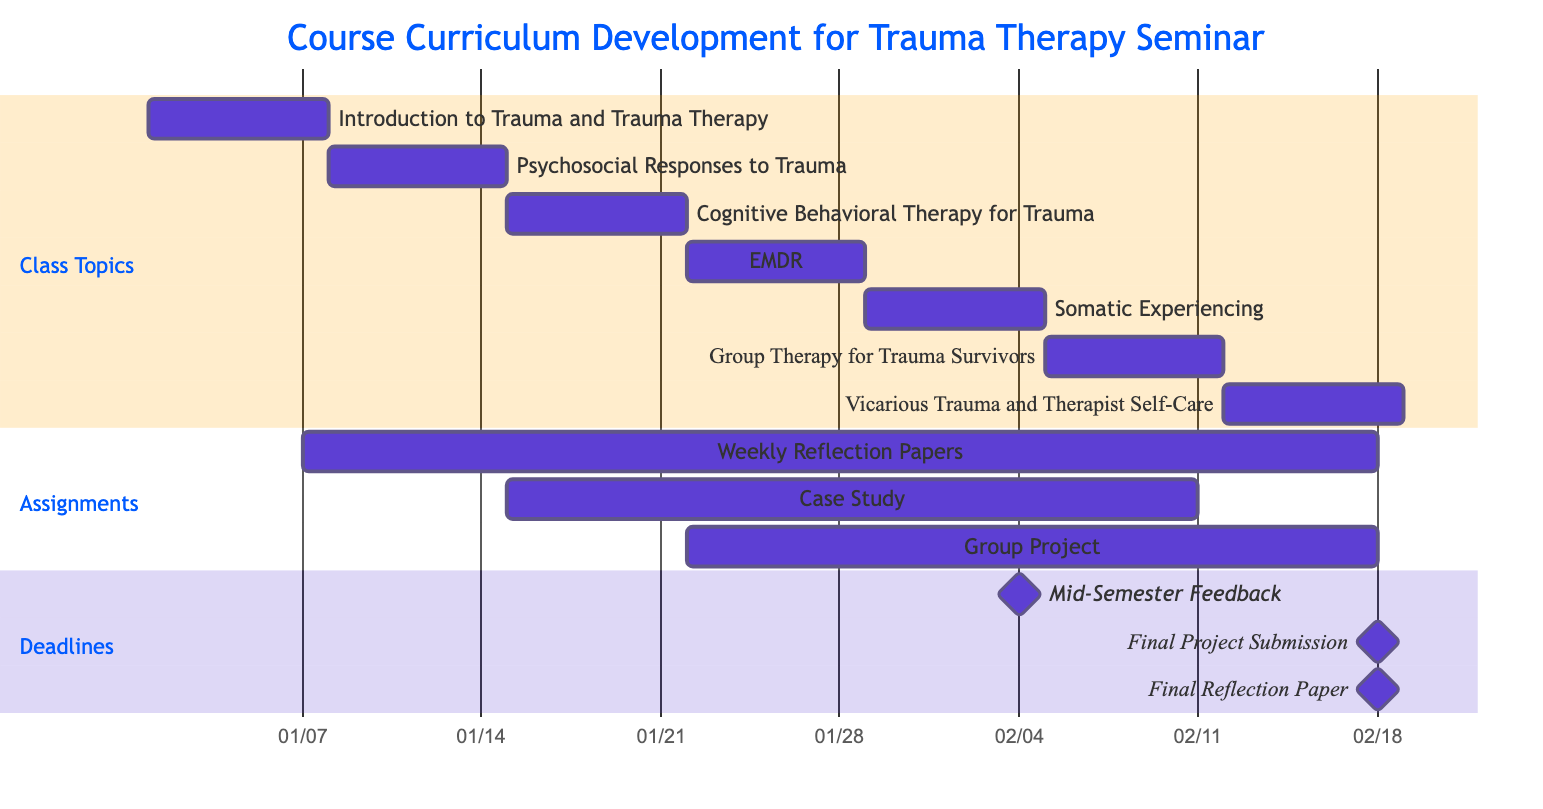What is the duration of the "Introduction to Trauma and Trauma Therapy" topic? The "Introduction to Trauma and Trauma Therapy" topic starts on January 1, 2024, and ends on January 7, 2024, which is a total of 7 days.
Answer: 7 days Which assignment is due on February 11, 2024? According to the assignments section, the "Case Study: Trauma Therapy Approaches" is due on February 11, 2024.
Answer: Case Study: Trauma Therapy Approaches What is the start date of "Group Therapy for Trauma Survivors"? In the Class Topics section, "Group Therapy for Trauma Survivors" is listed as starting on February 5, 2024.
Answer: February 5, 2024 How many class topics are there in total? The Class Topics section lists a total of 7 topics, which can be counted from the entries provided.
Answer: 7 Which assignment spans the longest time duration? The "Weekly Reflection Papers" assignment spans from January 7, 2024, to February 18, 2024, which is a longer range than any other assignment listed.
Answer: Weekly Reflection Papers What milestone deadline is set for February 18, 2024? There are multiple milestones listed for February 18, 2024, but specifically, the "Final Project Submission" is one of the key deadlines set on that date.
Answer: Final Project Submission What are the topics covered in the seminar immediately after "EMDR"? Following "EMDR," the next topic covered is "Somatic Experiencing," starting on January 29, 2024.
Answer: Somatic Experiencing When does the "Vicarious Trauma and Therapist Self-Care" topic conclude? The topic "Vicarious Trauma and Therapist Self-Care" ends on February 18, 2024, as indicated in the Class Topics section.
Answer: February 18, 2024 How many assignments have a specific due date of February 18, 2024? There are three assignments due on February 18, 2024. They are "Weekly Reflection Papers," "Group Project: Designing a Trauma Therapy Program," and "Final Reflection Paper."
Answer: 3 